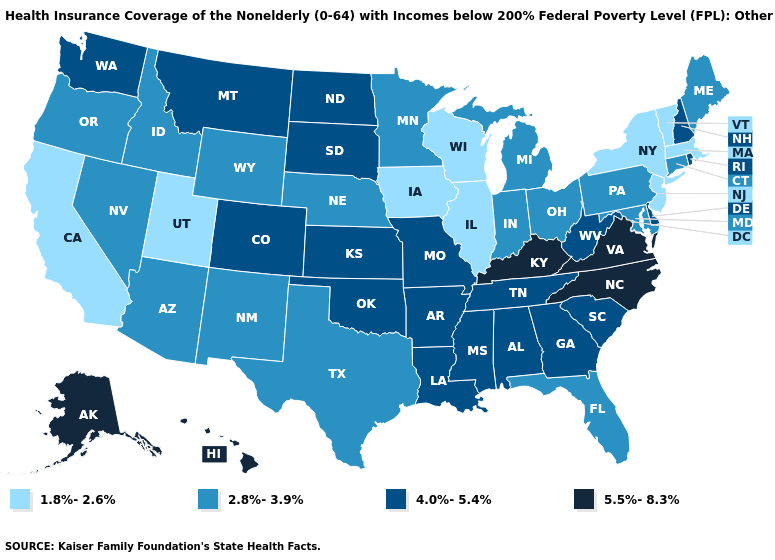Is the legend a continuous bar?
Quick response, please. No. Name the states that have a value in the range 2.8%-3.9%?
Answer briefly. Arizona, Connecticut, Florida, Idaho, Indiana, Maine, Maryland, Michigan, Minnesota, Nebraska, Nevada, New Mexico, Ohio, Oregon, Pennsylvania, Texas, Wyoming. Does Alaska have the highest value in the West?
Give a very brief answer. Yes. Name the states that have a value in the range 1.8%-2.6%?
Quick response, please. California, Illinois, Iowa, Massachusetts, New Jersey, New York, Utah, Vermont, Wisconsin. What is the highest value in the South ?
Concise answer only. 5.5%-8.3%. Name the states that have a value in the range 2.8%-3.9%?
Keep it brief. Arizona, Connecticut, Florida, Idaho, Indiana, Maine, Maryland, Michigan, Minnesota, Nebraska, Nevada, New Mexico, Ohio, Oregon, Pennsylvania, Texas, Wyoming. How many symbols are there in the legend?
Write a very short answer. 4. Among the states that border Tennessee , does Virginia have the lowest value?
Keep it brief. No. Does Wisconsin have a lower value than Utah?
Concise answer only. No. Is the legend a continuous bar?
Write a very short answer. No. Name the states that have a value in the range 2.8%-3.9%?
Write a very short answer. Arizona, Connecticut, Florida, Idaho, Indiana, Maine, Maryland, Michigan, Minnesota, Nebraska, Nevada, New Mexico, Ohio, Oregon, Pennsylvania, Texas, Wyoming. Name the states that have a value in the range 1.8%-2.6%?
Short answer required. California, Illinois, Iowa, Massachusetts, New Jersey, New York, Utah, Vermont, Wisconsin. Does New Hampshire have a lower value than Hawaii?
Write a very short answer. Yes. Does the first symbol in the legend represent the smallest category?
Concise answer only. Yes. Which states hav the highest value in the South?
Be succinct. Kentucky, North Carolina, Virginia. 